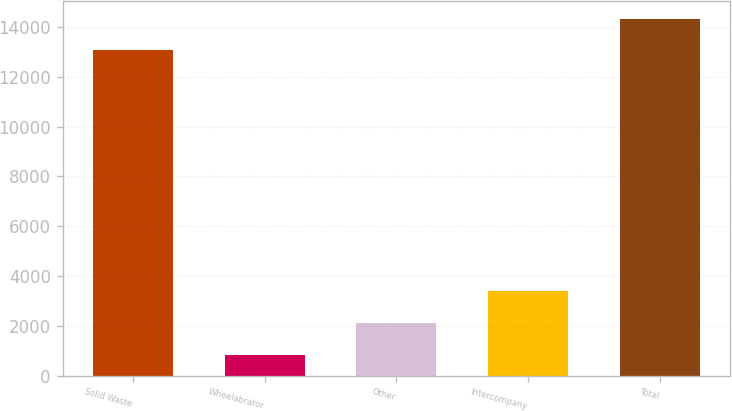Convert chart. <chart><loc_0><loc_0><loc_500><loc_500><bar_chart><fcel>Solid Waste<fcel>Wheelabrator<fcel>Other<fcel>Intercompany<fcel>Total<nl><fcel>13056<fcel>846<fcel>2126.3<fcel>3406.6<fcel>14336.3<nl></chart> 